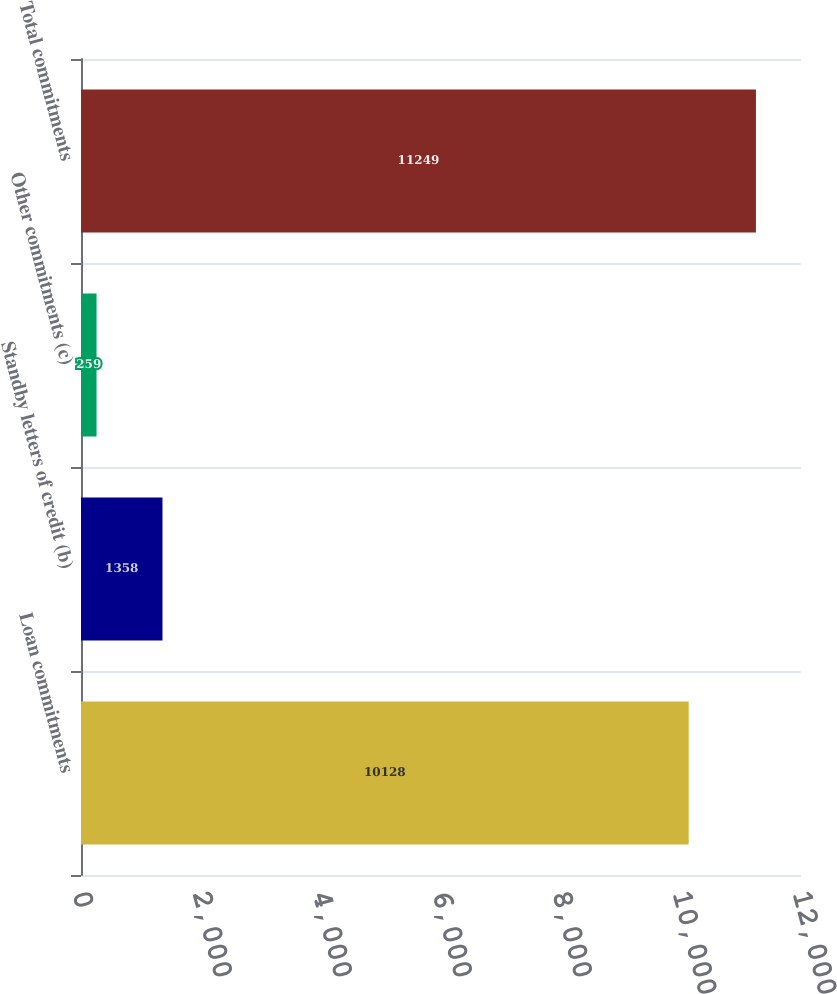<chart> <loc_0><loc_0><loc_500><loc_500><bar_chart><fcel>Loan commitments<fcel>Standby letters of credit (b)<fcel>Other commitments (c)<fcel>Total commitments<nl><fcel>10128<fcel>1358<fcel>259<fcel>11249<nl></chart> 